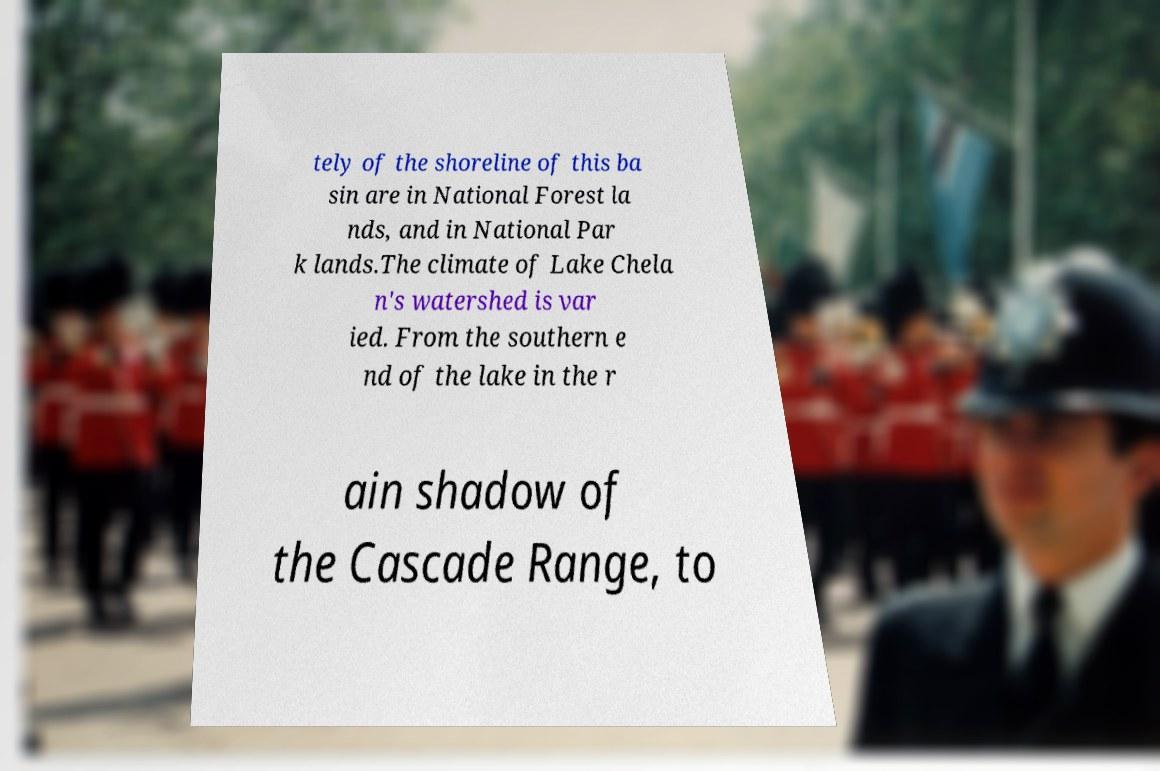Please identify and transcribe the text found in this image. tely of the shoreline of this ba sin are in National Forest la nds, and in National Par k lands.The climate of Lake Chela n's watershed is var ied. From the southern e nd of the lake in the r ain shadow of the Cascade Range, to 